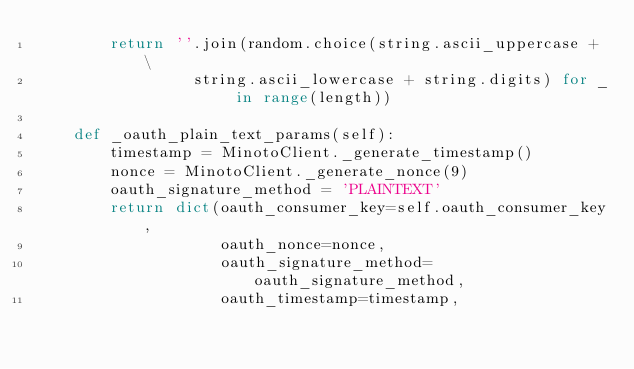<code> <loc_0><loc_0><loc_500><loc_500><_Python_>        return ''.join(random.choice(string.ascii_uppercase + \
                 string.ascii_lowercase + string.digits) for _ in range(length))

    def _oauth_plain_text_params(self):
        timestamp = MinotoClient._generate_timestamp()
        nonce = MinotoClient._generate_nonce(9)
        oauth_signature_method = 'PLAINTEXT'
        return dict(oauth_consumer_key=self.oauth_consumer_key,
                    oauth_nonce=nonce,
                    oauth_signature_method=oauth_signature_method,
                    oauth_timestamp=timestamp,</code> 